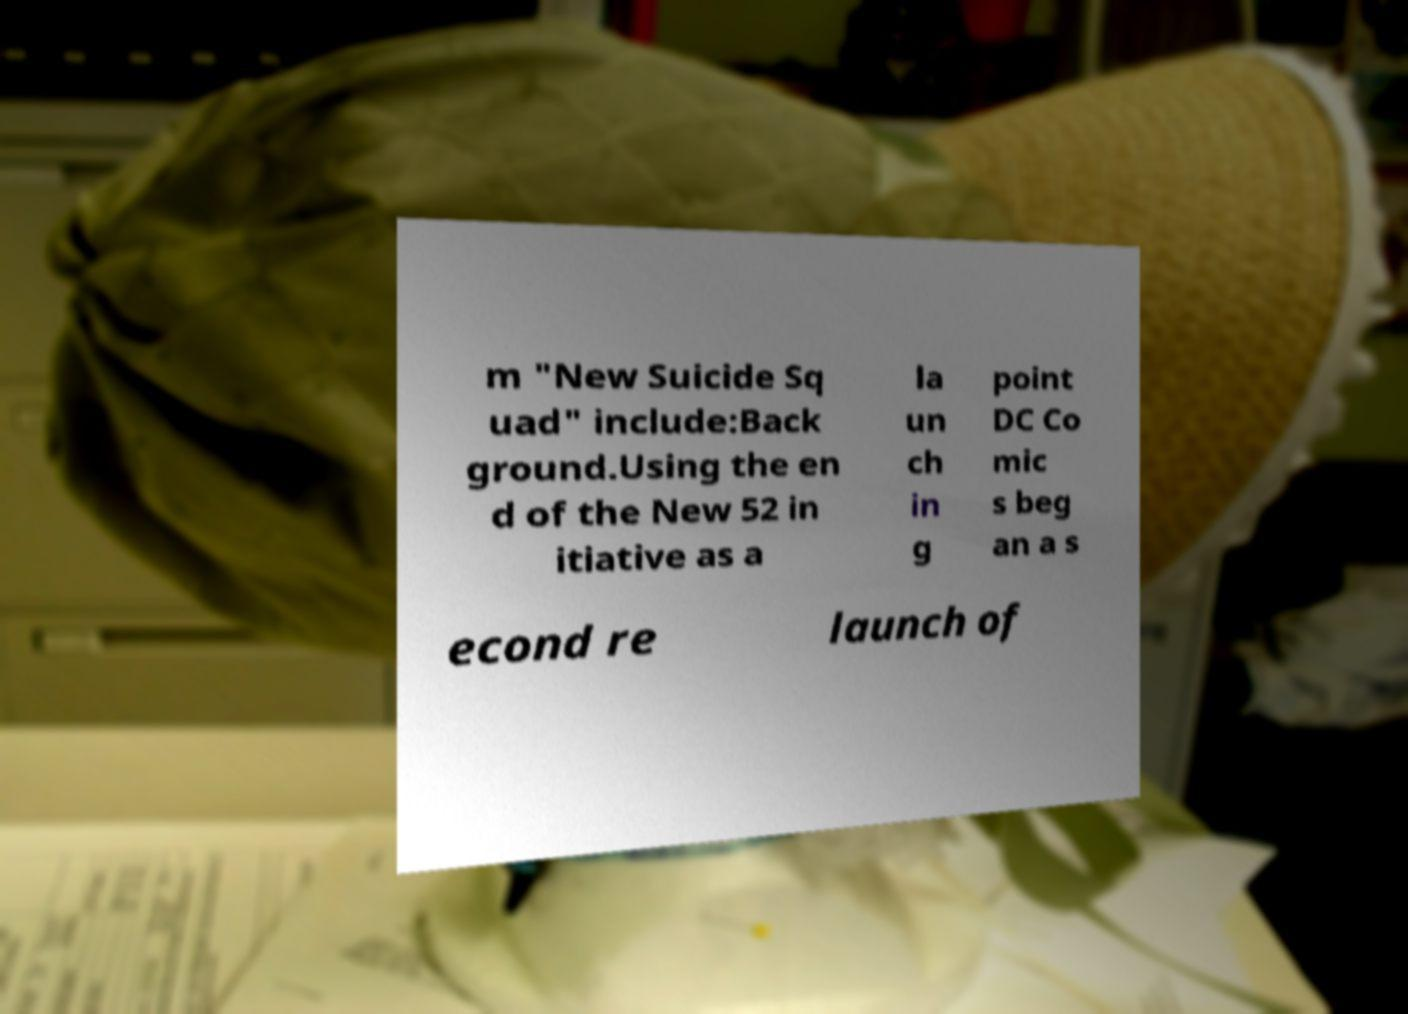Can you read and provide the text displayed in the image?This photo seems to have some interesting text. Can you extract and type it out for me? m "New Suicide Sq uad" include:Back ground.Using the en d of the New 52 in itiative as a la un ch in g point DC Co mic s beg an a s econd re launch of 